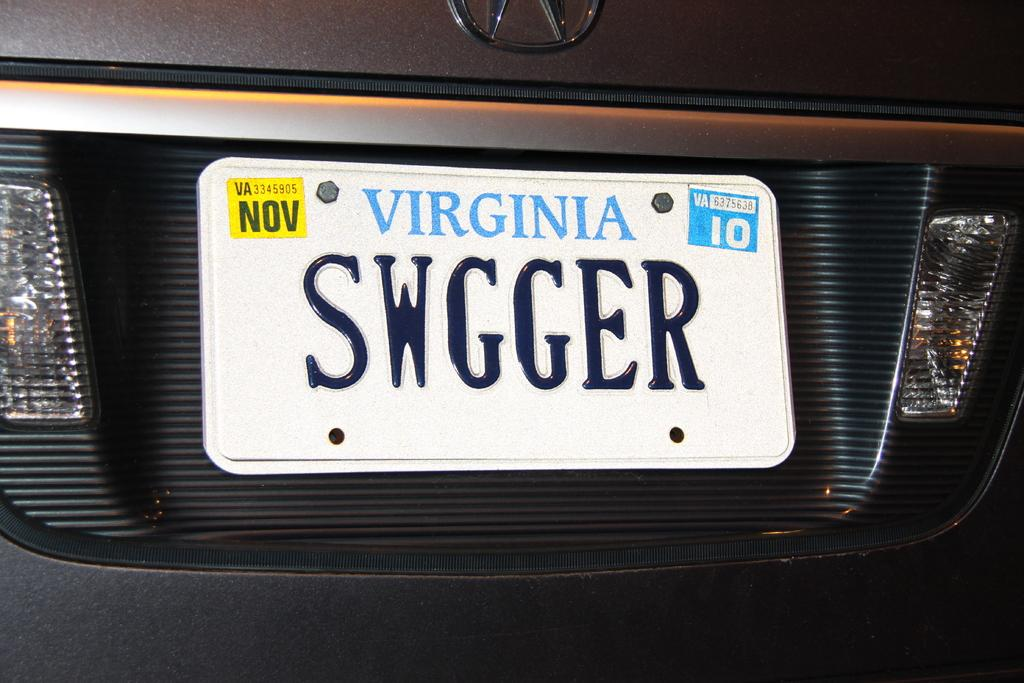<image>
Render a clear and concise summary of the photo. White Virginia license plate which says SWGGER on it. 